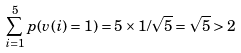<formula> <loc_0><loc_0><loc_500><loc_500>\sum _ { i = 1 } ^ { 5 } p ( v ( i ) = 1 ) = 5 \times 1 / \sqrt { 5 } = \sqrt { 5 } > 2</formula> 